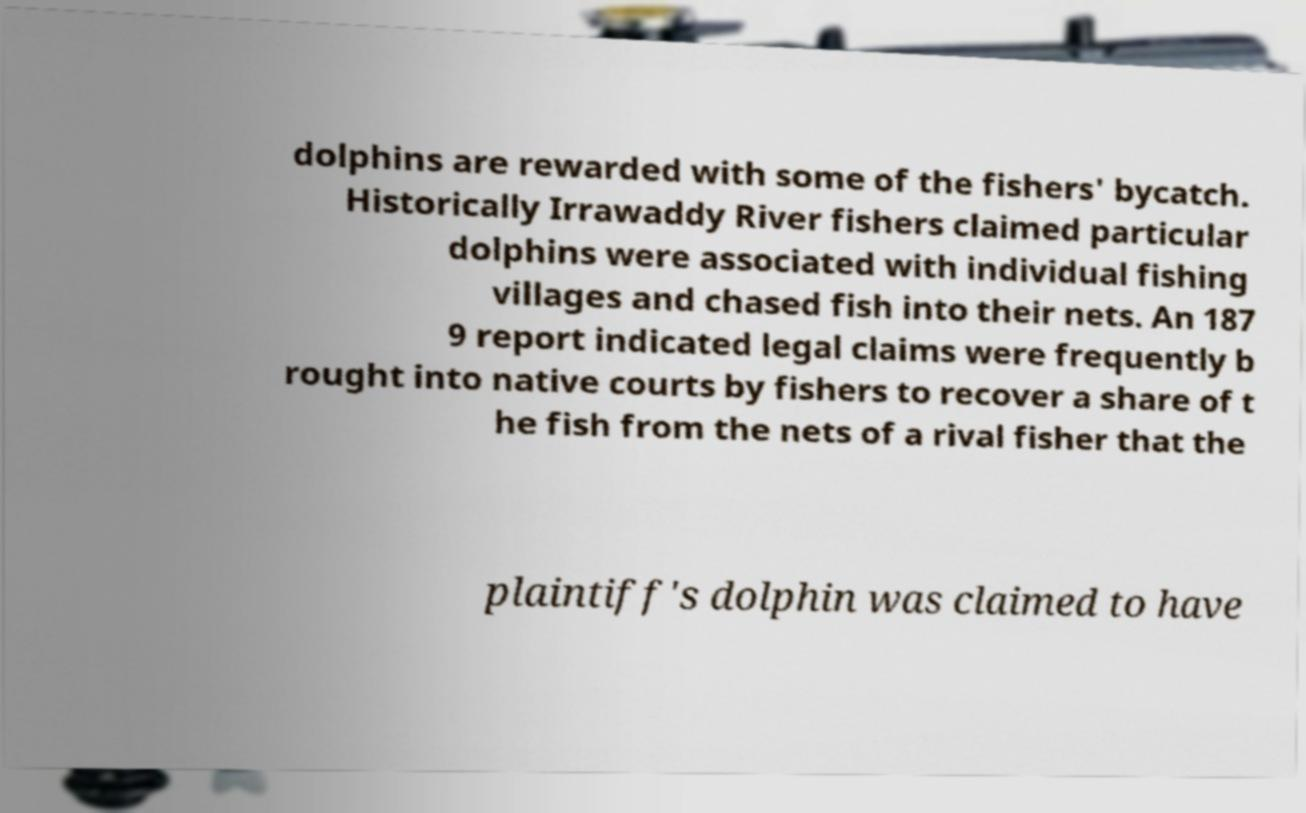For documentation purposes, I need the text within this image transcribed. Could you provide that? dolphins are rewarded with some of the fishers' bycatch. Historically Irrawaddy River fishers claimed particular dolphins were associated with individual fishing villages and chased fish into their nets. An 187 9 report indicated legal claims were frequently b rought into native courts by fishers to recover a share of t he fish from the nets of a rival fisher that the plaintiff's dolphin was claimed to have 